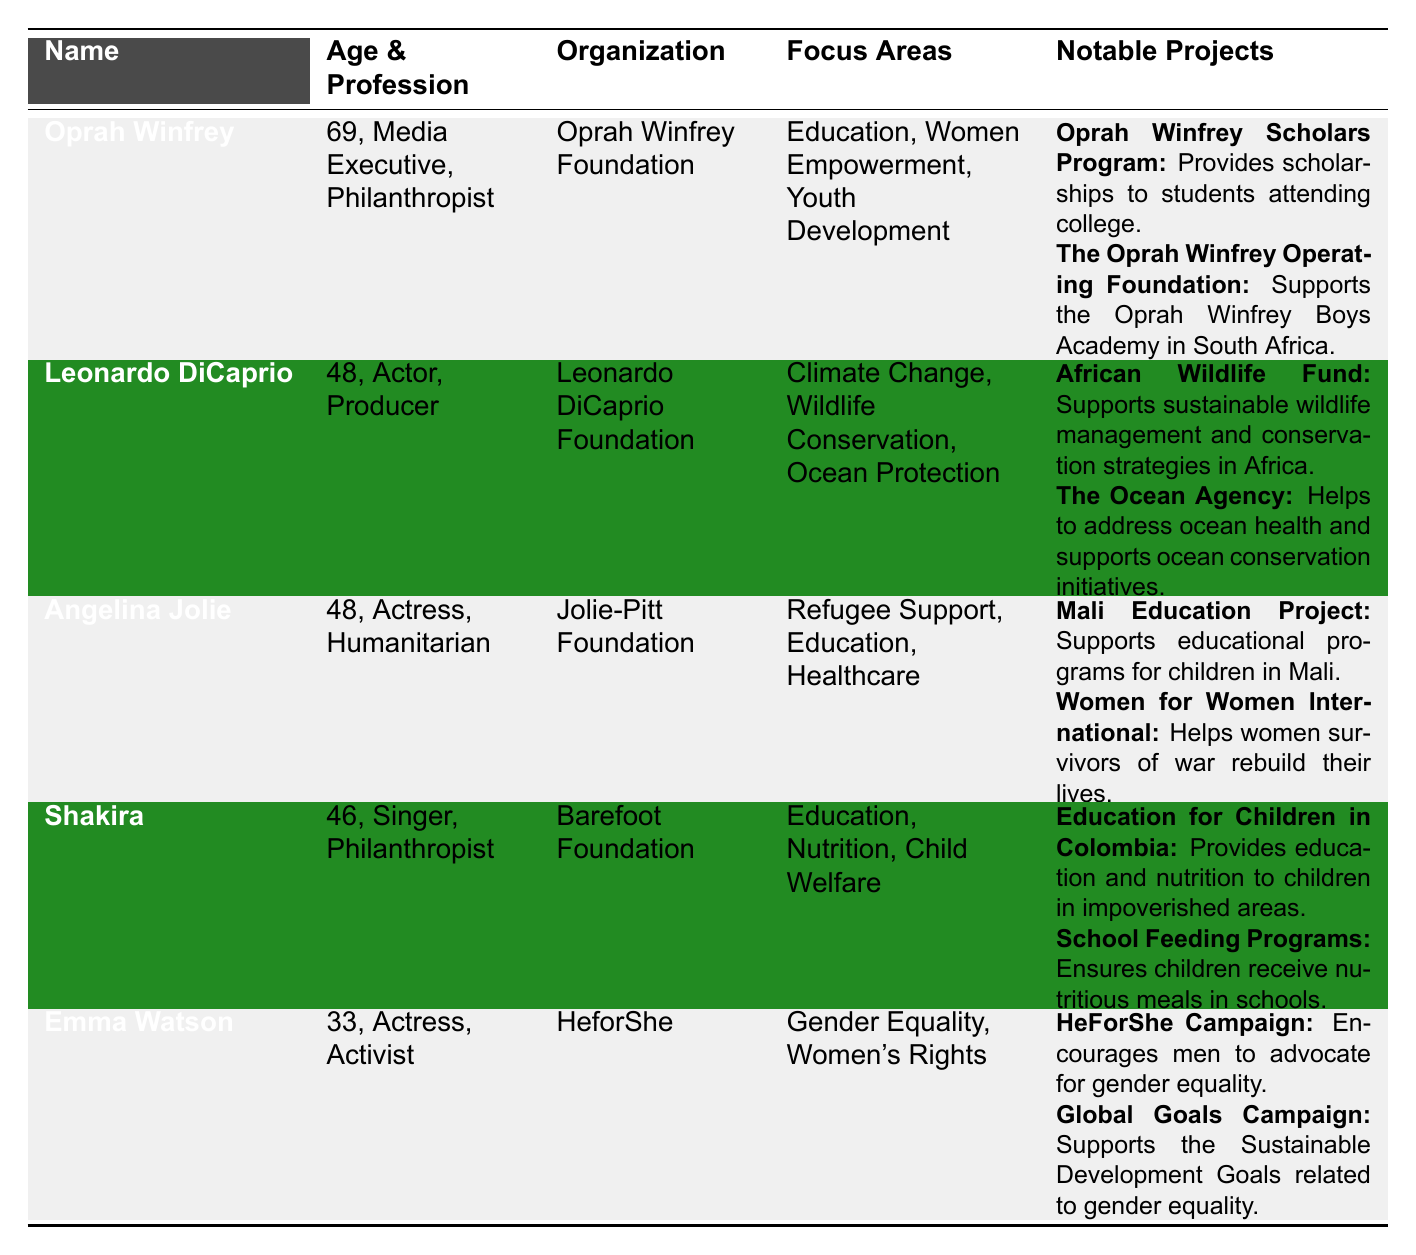What profession is Oprah Winfrey known for? Oprah Winfrey's profession can be found in the 'Profession' column where it states she is a 'Media Executive, Philanthropist'.
Answer: Media Executive, Philanthropist What are the focus areas of the Leonardo DiCaprio Foundation? The focus areas for Leonardo DiCaprio's philanthropic organization are listed in the 'Focus Areas' column, which includes 'Climate Change, Wildlife Conservation, Ocean Protection'.
Answer: Climate Change, Wildlife Conservation, Ocean Protection Is Shakira involved in healthcare projects through her philanthropy? In the table, Shakira's focus areas do not include healthcare, she is focused on 'Education, Nutrition, Child Welfare', hence the answer is no.
Answer: No How many notable projects does Angelina Jolie have listed? If we count the notable projects for Angelina Jolie in the 'Notable Projects' column, there are two listed: 'Mali Education Project' and 'Women for Women International'.
Answer: 2 Which public figure focuses on gender equality and women's rights? By examining the 'Focus Areas' column, we can see that Emma Watson is the public figure focusing on 'Gender Equality, Women's Rights'.
Answer: Emma Watson How many years older is Shakira compared to Emma Watson? To find the age difference, subtract Emma Watson's age (33) from Shakira's age (46), which gives us a difference of 13 years.
Answer: 13 years What projects are notable under Oprah Winfrey's philanthropic organization? Oprah Winfrey has two notable projects listed: 'Oprah Winfrey Scholars Program' and 'The Oprah Winfrey Operating Foundation'. Both are included in the 'Notable Projects' column.
Answer: Oprah Winfrey Scholars Program, The Oprah Winfrey Operating Foundation Do both Angelina Jolie and Leonardo DiCaprio support education-related initiatives? Looking at the data, Angelina Jolie's focus includes 'Education', while Leonardo DiCaprio's does not include education but focuses on environmental issues, so the answer is no.
Answer: No Which public figure has the oldest age? The ages of the public figures can be found in the 'Age & Profession' column, and by comparing, we see that Oprah Winfrey, who is 69 years old, is the oldest.
Answer: Oprah Winfrey 